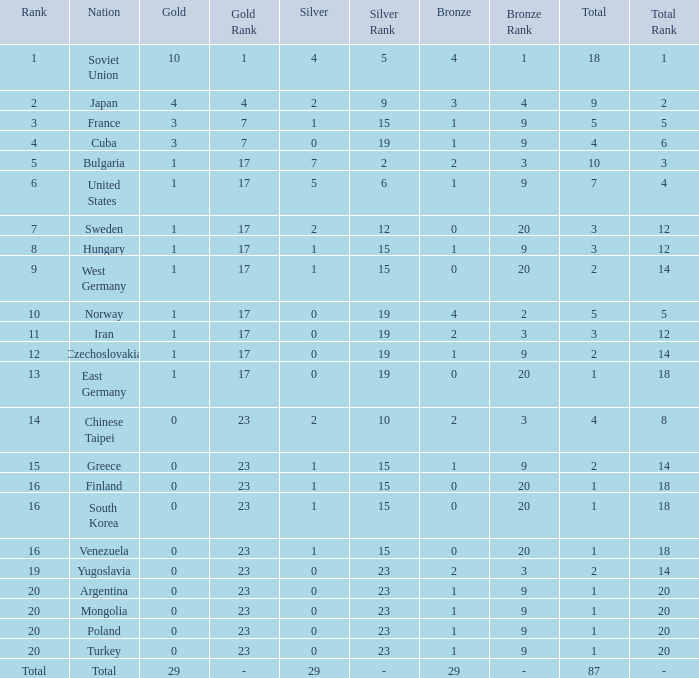What is the sum of gold medals for a rank of 14? 0.0. 